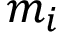Convert formula to latex. <formula><loc_0><loc_0><loc_500><loc_500>m _ { i }</formula> 